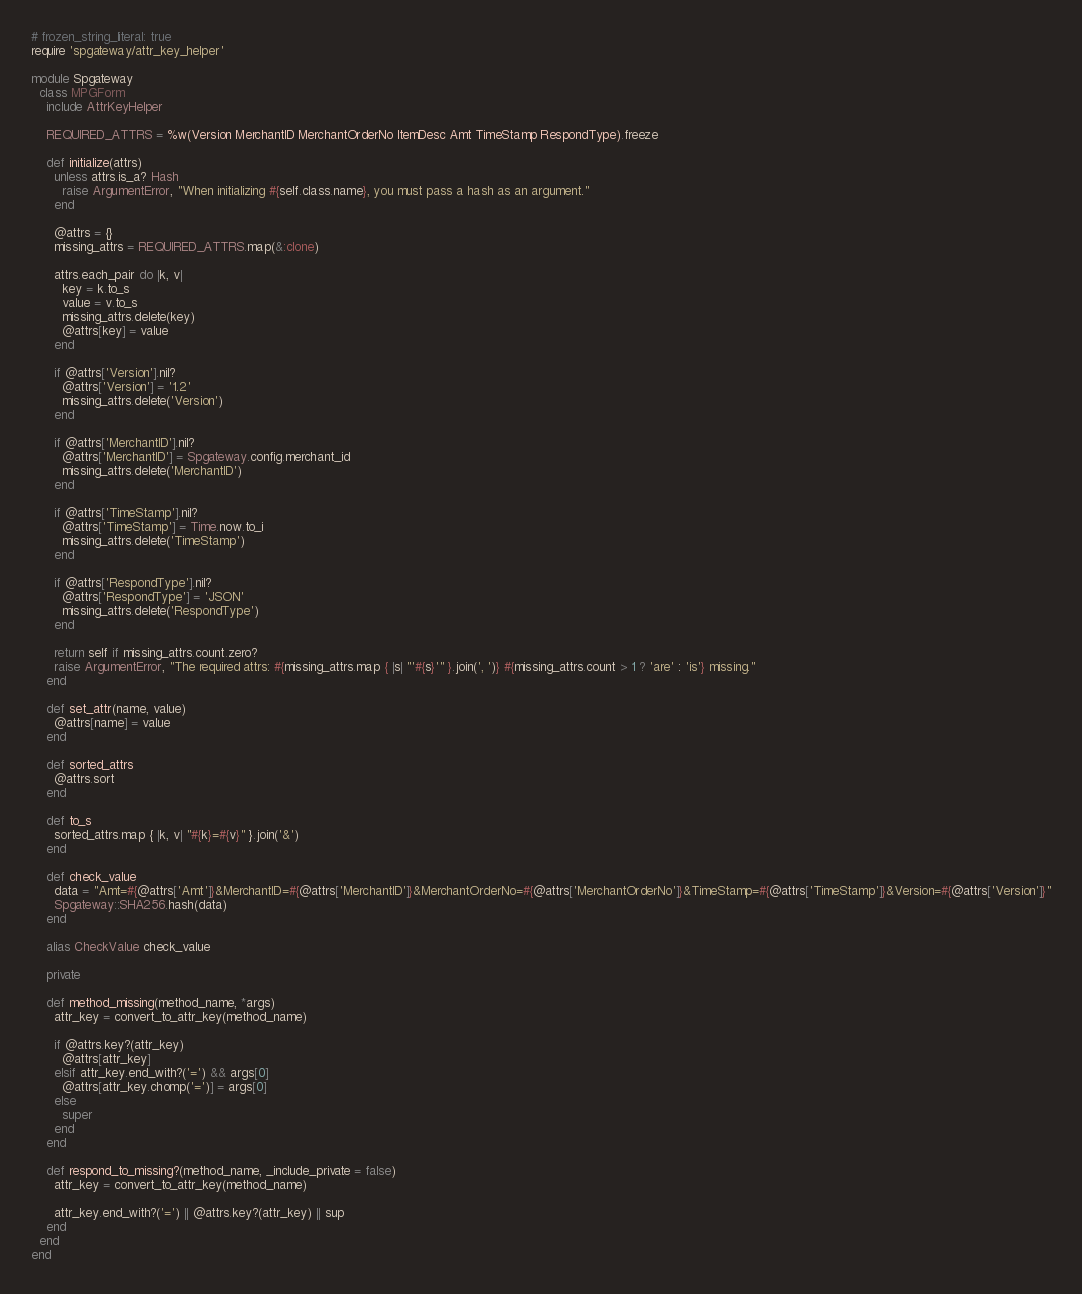<code> <loc_0><loc_0><loc_500><loc_500><_Ruby_># frozen_string_literal: true
require 'spgateway/attr_key_helper'

module Spgateway
  class MPGForm
    include AttrKeyHelper

    REQUIRED_ATTRS = %w(Version MerchantID MerchantOrderNo ItemDesc Amt TimeStamp RespondType).freeze

    def initialize(attrs)
      unless attrs.is_a? Hash
        raise ArgumentError, "When initializing #{self.class.name}, you must pass a hash as an argument."
      end

      @attrs = {}
      missing_attrs = REQUIRED_ATTRS.map(&:clone)

      attrs.each_pair do |k, v|
        key = k.to_s
        value = v.to_s
        missing_attrs.delete(key)
        @attrs[key] = value
      end

      if @attrs['Version'].nil?
        @attrs['Version'] = '1.2'
        missing_attrs.delete('Version')
      end

      if @attrs['MerchantID'].nil?
        @attrs['MerchantID'] = Spgateway.config.merchant_id
        missing_attrs.delete('MerchantID')
      end

      if @attrs['TimeStamp'].nil?
        @attrs['TimeStamp'] = Time.now.to_i
        missing_attrs.delete('TimeStamp')
      end

      if @attrs['RespondType'].nil?
        @attrs['RespondType'] = 'JSON'
        missing_attrs.delete('RespondType')
      end

      return self if missing_attrs.count.zero?
      raise ArgumentError, "The required attrs: #{missing_attrs.map { |s| "'#{s}'" }.join(', ')} #{missing_attrs.count > 1 ? 'are' : 'is'} missing."
    end

    def set_attr(name, value)
      @attrs[name] = value
    end

    def sorted_attrs
      @attrs.sort
    end

    def to_s
      sorted_attrs.map { |k, v| "#{k}=#{v}" }.join('&')
    end

    def check_value
      data = "Amt=#{@attrs['Amt']}&MerchantID=#{@attrs['MerchantID']}&MerchantOrderNo=#{@attrs['MerchantOrderNo']}&TimeStamp=#{@attrs['TimeStamp']}&Version=#{@attrs['Version']}"
      Spgateway::SHA256.hash(data)
    end

    alias CheckValue check_value

    private

    def method_missing(method_name, *args)
      attr_key = convert_to_attr_key(method_name)

      if @attrs.key?(attr_key)
        @attrs[attr_key]
      elsif attr_key.end_with?('=') && args[0]
        @attrs[attr_key.chomp('=')] = args[0]
      else
        super
      end
    end

    def respond_to_missing?(method_name, _include_private = false)
      attr_key = convert_to_attr_key(method_name)

      attr_key.end_with?('=') || @attrs.key?(attr_key) || sup
    end
  end
end
</code> 